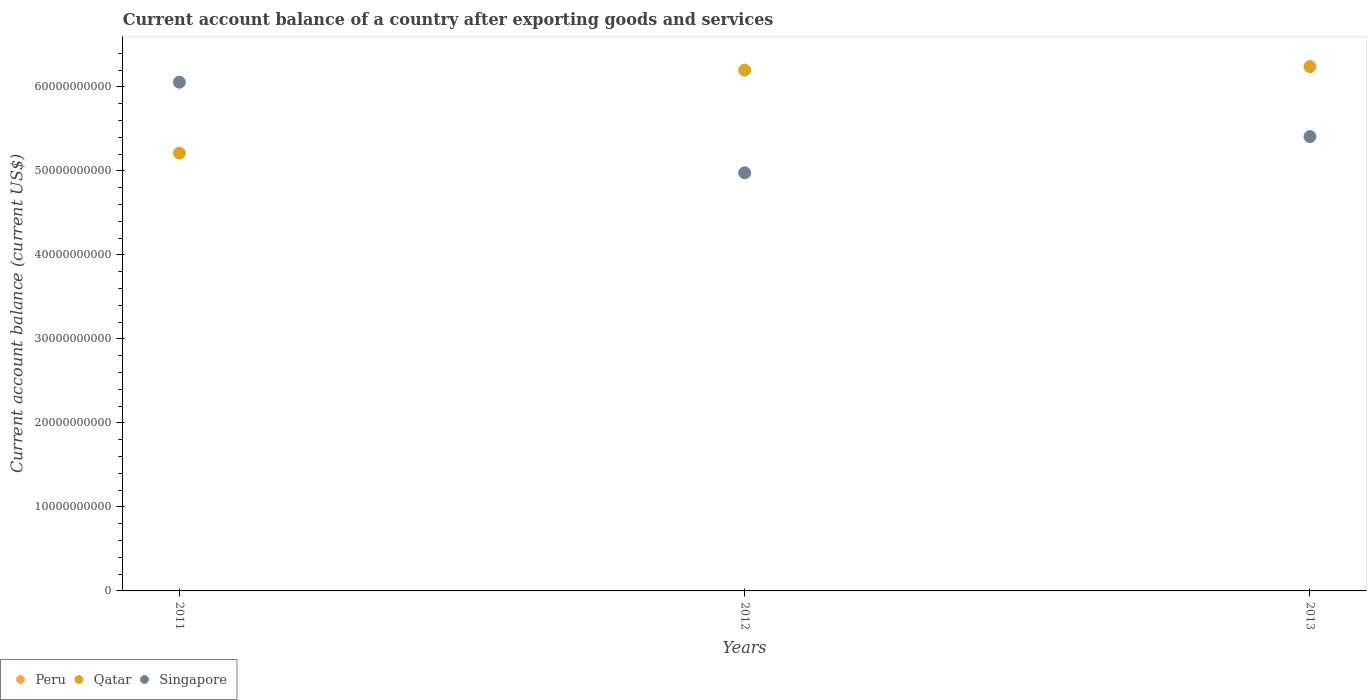How many different coloured dotlines are there?
Your answer should be compact. 2. What is the account balance in Qatar in 2011?
Provide a short and direct response. 5.21e+1. Across all years, what is the maximum account balance in Qatar?
Offer a very short reply. 6.24e+1. Across all years, what is the minimum account balance in Peru?
Offer a terse response. 0. What is the total account balance in Singapore in the graph?
Ensure brevity in your answer.  1.64e+11. What is the difference between the account balance in Singapore in 2011 and that in 2013?
Offer a very short reply. 6.48e+09. What is the difference between the account balance in Peru in 2013 and the account balance in Singapore in 2012?
Your answer should be compact. -4.98e+1. What is the average account balance in Singapore per year?
Your response must be concise. 5.48e+1. In the year 2012, what is the difference between the account balance in Qatar and account balance in Singapore?
Your answer should be compact. 1.22e+1. In how many years, is the account balance in Peru greater than 58000000000 US$?
Give a very brief answer. 0. What is the ratio of the account balance in Singapore in 2011 to that in 2012?
Your answer should be very brief. 1.22. Is the account balance in Qatar in 2012 less than that in 2013?
Provide a short and direct response. Yes. What is the difference between the highest and the second highest account balance in Qatar?
Provide a succinct answer. 4.18e+08. What is the difference between the highest and the lowest account balance in Qatar?
Provide a succinct answer. 1.03e+1. In how many years, is the account balance in Qatar greater than the average account balance in Qatar taken over all years?
Your response must be concise. 2. Is the sum of the account balance in Singapore in 2012 and 2013 greater than the maximum account balance in Peru across all years?
Provide a short and direct response. Yes. Is it the case that in every year, the sum of the account balance in Qatar and account balance in Singapore  is greater than the account balance in Peru?
Your answer should be very brief. Yes. Does the account balance in Peru monotonically increase over the years?
Provide a short and direct response. No. Is the account balance in Singapore strictly greater than the account balance in Peru over the years?
Your answer should be very brief. Yes. Is the account balance in Qatar strictly less than the account balance in Peru over the years?
Ensure brevity in your answer.  No. How many years are there in the graph?
Make the answer very short. 3. Does the graph contain any zero values?
Your answer should be very brief. Yes. How are the legend labels stacked?
Provide a succinct answer. Horizontal. What is the title of the graph?
Give a very brief answer. Current account balance of a country after exporting goods and services. Does "Lower middle income" appear as one of the legend labels in the graph?
Provide a short and direct response. No. What is the label or title of the X-axis?
Give a very brief answer. Years. What is the label or title of the Y-axis?
Offer a very short reply. Current account balance (current US$). What is the Current account balance (current US$) in Qatar in 2011?
Your answer should be very brief. 5.21e+1. What is the Current account balance (current US$) of Singapore in 2011?
Keep it short and to the point. 6.06e+1. What is the Current account balance (current US$) of Qatar in 2012?
Ensure brevity in your answer.  6.20e+1. What is the Current account balance (current US$) in Singapore in 2012?
Your response must be concise. 4.98e+1. What is the Current account balance (current US$) in Peru in 2013?
Keep it short and to the point. 0. What is the Current account balance (current US$) in Qatar in 2013?
Provide a succinct answer. 6.24e+1. What is the Current account balance (current US$) in Singapore in 2013?
Offer a very short reply. 5.41e+1. Across all years, what is the maximum Current account balance (current US$) of Qatar?
Provide a succinct answer. 6.24e+1. Across all years, what is the maximum Current account balance (current US$) of Singapore?
Offer a very short reply. 6.06e+1. Across all years, what is the minimum Current account balance (current US$) of Qatar?
Make the answer very short. 5.21e+1. Across all years, what is the minimum Current account balance (current US$) in Singapore?
Make the answer very short. 4.98e+1. What is the total Current account balance (current US$) of Qatar in the graph?
Your answer should be very brief. 1.77e+11. What is the total Current account balance (current US$) in Singapore in the graph?
Your response must be concise. 1.64e+11. What is the difference between the Current account balance (current US$) of Qatar in 2011 and that in 2012?
Give a very brief answer. -9.88e+09. What is the difference between the Current account balance (current US$) of Singapore in 2011 and that in 2012?
Offer a very short reply. 1.08e+1. What is the difference between the Current account balance (current US$) of Qatar in 2011 and that in 2013?
Offer a very short reply. -1.03e+1. What is the difference between the Current account balance (current US$) in Singapore in 2011 and that in 2013?
Give a very brief answer. 6.48e+09. What is the difference between the Current account balance (current US$) of Qatar in 2012 and that in 2013?
Ensure brevity in your answer.  -4.18e+08. What is the difference between the Current account balance (current US$) of Singapore in 2012 and that in 2013?
Provide a short and direct response. -4.31e+09. What is the difference between the Current account balance (current US$) in Qatar in 2011 and the Current account balance (current US$) in Singapore in 2012?
Provide a short and direct response. 2.35e+09. What is the difference between the Current account balance (current US$) of Qatar in 2011 and the Current account balance (current US$) of Singapore in 2013?
Provide a succinct answer. -1.96e+09. What is the difference between the Current account balance (current US$) in Qatar in 2012 and the Current account balance (current US$) in Singapore in 2013?
Your answer should be very brief. 7.92e+09. What is the average Current account balance (current US$) in Qatar per year?
Provide a short and direct response. 5.88e+1. What is the average Current account balance (current US$) in Singapore per year?
Your response must be concise. 5.48e+1. In the year 2011, what is the difference between the Current account balance (current US$) in Qatar and Current account balance (current US$) in Singapore?
Make the answer very short. -8.44e+09. In the year 2012, what is the difference between the Current account balance (current US$) of Qatar and Current account balance (current US$) of Singapore?
Keep it short and to the point. 1.22e+1. In the year 2013, what is the difference between the Current account balance (current US$) of Qatar and Current account balance (current US$) of Singapore?
Provide a short and direct response. 8.33e+09. What is the ratio of the Current account balance (current US$) of Qatar in 2011 to that in 2012?
Provide a short and direct response. 0.84. What is the ratio of the Current account balance (current US$) in Singapore in 2011 to that in 2012?
Ensure brevity in your answer.  1.22. What is the ratio of the Current account balance (current US$) in Qatar in 2011 to that in 2013?
Make the answer very short. 0.84. What is the ratio of the Current account balance (current US$) of Singapore in 2011 to that in 2013?
Your answer should be very brief. 1.12. What is the ratio of the Current account balance (current US$) of Qatar in 2012 to that in 2013?
Provide a short and direct response. 0.99. What is the ratio of the Current account balance (current US$) of Singapore in 2012 to that in 2013?
Give a very brief answer. 0.92. What is the difference between the highest and the second highest Current account balance (current US$) in Qatar?
Make the answer very short. 4.18e+08. What is the difference between the highest and the second highest Current account balance (current US$) of Singapore?
Ensure brevity in your answer.  6.48e+09. What is the difference between the highest and the lowest Current account balance (current US$) in Qatar?
Offer a very short reply. 1.03e+1. What is the difference between the highest and the lowest Current account balance (current US$) of Singapore?
Make the answer very short. 1.08e+1. 